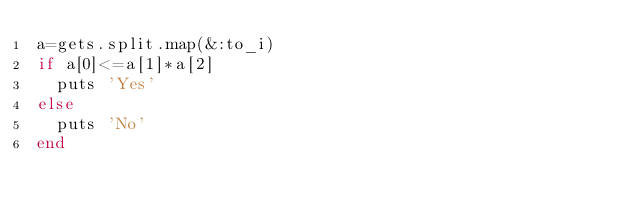<code> <loc_0><loc_0><loc_500><loc_500><_Ruby_>a=gets.split.map(&:to_i)
if a[0]<=a[1]*a[2]
  puts 'Yes'
else
  puts 'No'
end</code> 